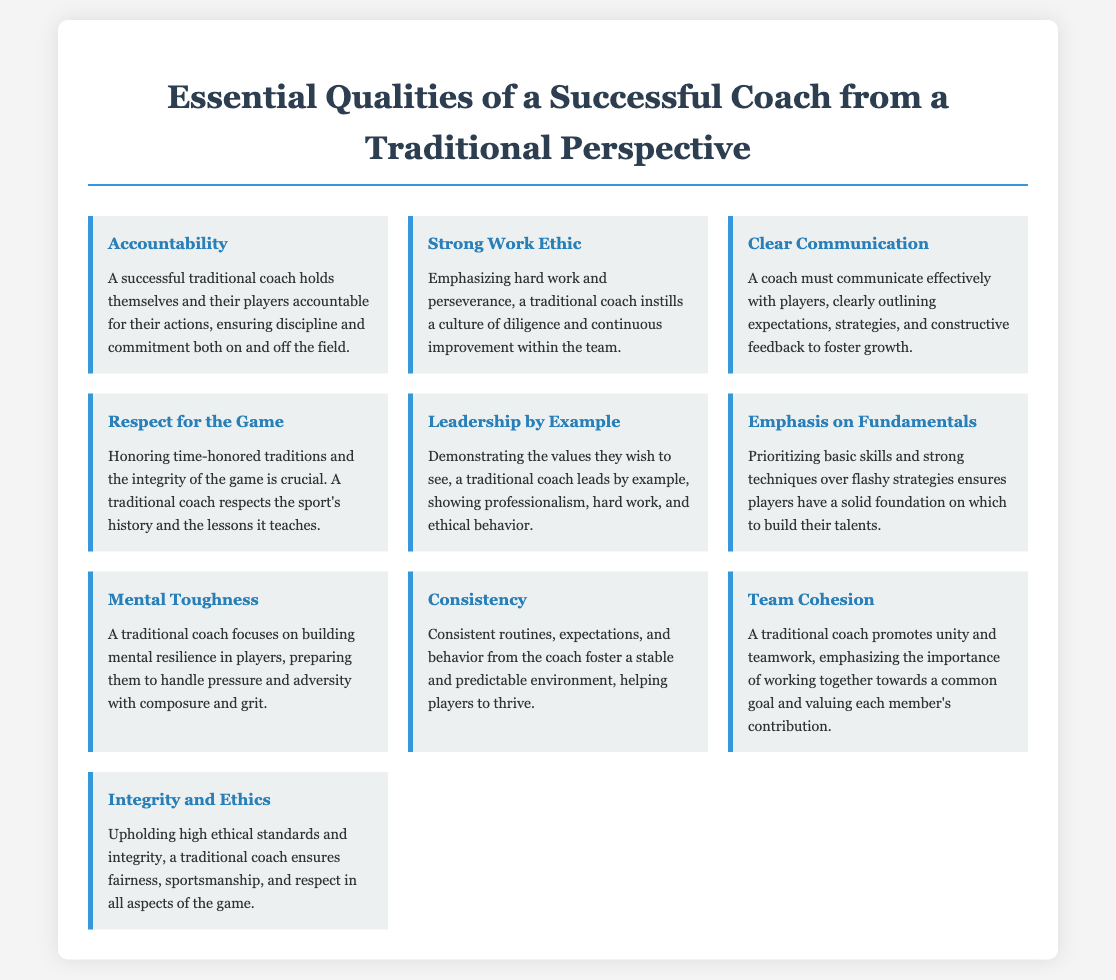What is one essential quality of a successful coach? The document lists several essential qualities, one of which is "Accountability."
Answer: Accountability How many qualities are listed in the infographic? The document details ten essential qualities of a successful coach.
Answer: Ten What quality emphasizes the importance of hard work? The quality that highlights hard work and perseverance is referred to as "Strong Work Ethic."
Answer: Strong Work Ethic Which quality focuses on building resilience in players? The quality that focuses on mental resilience and handling pressure is "Mental Toughness."
Answer: Mental Toughness What does "Respect for the Game" signify for a traditional coach? The quality emphasizes honoring traditions and the integrity of the game.
Answer: Honoring traditions and integrity In which quality is the concept of teamwork highlighted? The quality referring to teamwork and unity is "Team Cohesion."
Answer: Team Cohesion What quality advocates for high ethical standards? The quality that promotes ethical behavior is "Integrity and Ethics."
Answer: Integrity and Ethics Which quality is tied to routines and stability? The quality associated with consistency and predictability is "Consistency."
Answer: Consistency What quality involves clear communication of expectations? The quality that concerns effective communication is "Clear Communication."
Answer: Clear Communication 